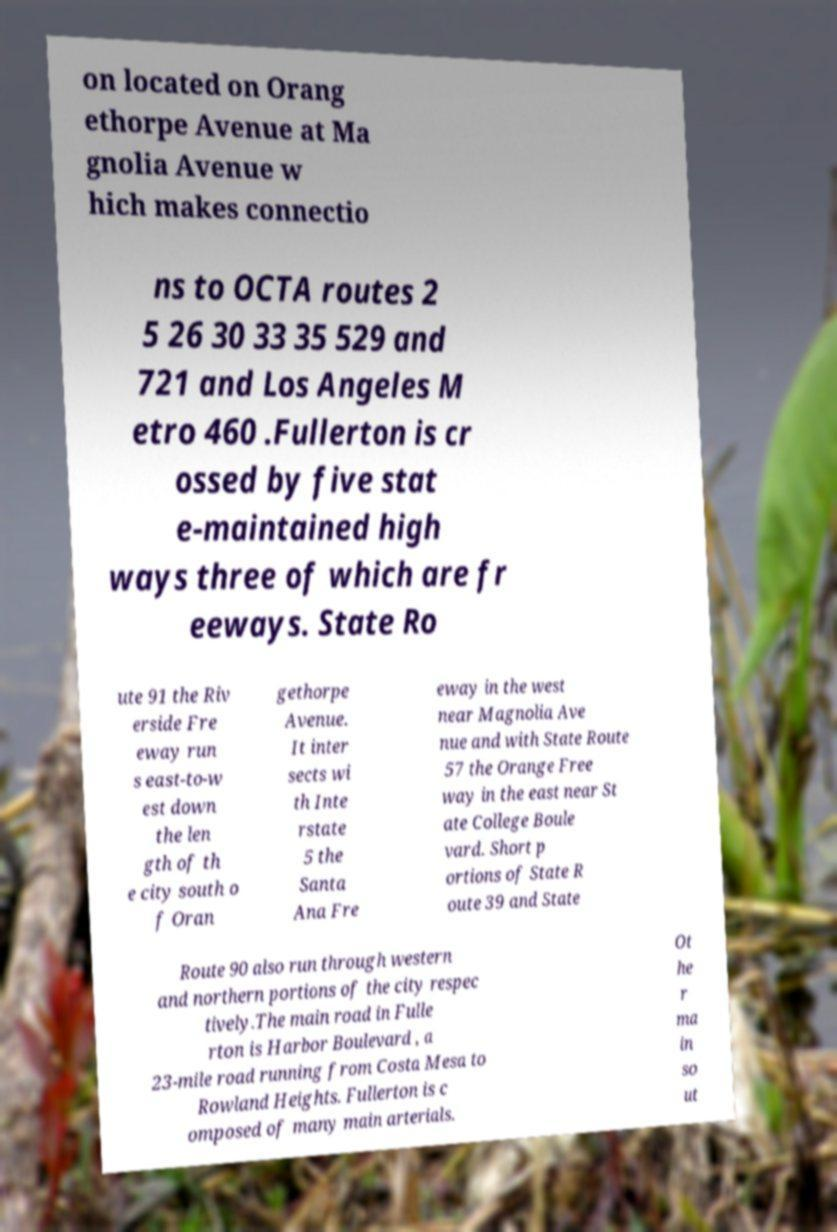There's text embedded in this image that I need extracted. Can you transcribe it verbatim? on located on Orang ethorpe Avenue at Ma gnolia Avenue w hich makes connectio ns to OCTA routes 2 5 26 30 33 35 529 and 721 and Los Angeles M etro 460 .Fullerton is cr ossed by five stat e-maintained high ways three of which are fr eeways. State Ro ute 91 the Riv erside Fre eway run s east-to-w est down the len gth of th e city south o f Oran gethorpe Avenue. It inter sects wi th Inte rstate 5 the Santa Ana Fre eway in the west near Magnolia Ave nue and with State Route 57 the Orange Free way in the east near St ate College Boule vard. Short p ortions of State R oute 39 and State Route 90 also run through western and northern portions of the city respec tively.The main road in Fulle rton is Harbor Boulevard , a 23-mile road running from Costa Mesa to Rowland Heights. Fullerton is c omposed of many main arterials. Ot he r ma in so ut 